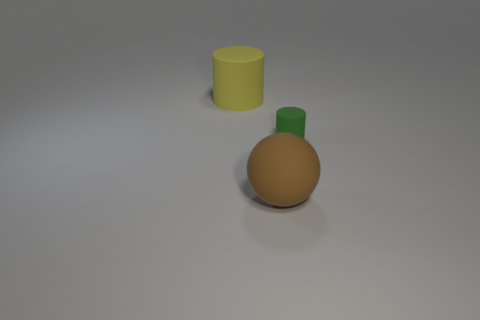There is a cylinder that is behind the small cylinder; what size is it?
Provide a short and direct response. Large. What number of objects are big things or objects that are to the right of the rubber ball?
Your answer should be very brief. 3. What number of other things are the same size as the brown object?
Provide a succinct answer. 1. What is the material of the yellow thing that is the same shape as the green rubber thing?
Your answer should be very brief. Rubber. Is the number of yellow cylinders on the left side of the yellow matte cylinder greater than the number of small red things?
Give a very brief answer. No. Is there any other thing that has the same color as the small rubber cylinder?
Offer a very short reply. No. What is the shape of the other big object that is made of the same material as the large yellow thing?
Ensure brevity in your answer.  Sphere. Do the cylinder to the right of the big brown rubber object and the big cylinder have the same material?
Provide a short and direct response. Yes. There is a big rubber thing that is in front of the yellow matte cylinder; is its color the same as the big rubber object that is left of the large brown matte sphere?
Offer a very short reply. No. How many things are both right of the big sphere and left of the tiny cylinder?
Your response must be concise. 0. 